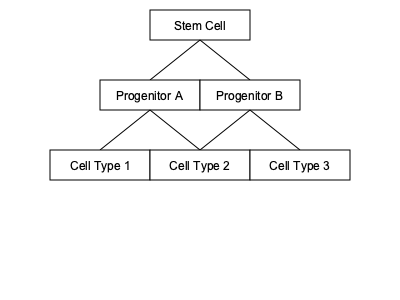In the stem cell differentiation flowchart above, how many distinct cell types are produced from the initial stem cell? To determine the number of distinct cell types produced from the initial stem cell, we need to follow the differentiation pathway:

1. The process starts with a single stem cell at the top of the flowchart.

2. This stem cell differentiates into two types of progenitor cells: Progenitor A and Progenitor B. These are intermediate cell types and not considered final differentiated cells.

3. Progenitor A then differentiates into two distinct cell types: Cell Type 1 and Cell Type 2.

4. Progenitor B differentiates into Cell Type 3.

5. Counting the final differentiated cells at the bottom of the flowchart, we can see three distinct cell types: Cell Type 1, Cell Type 2, and Cell Type 3.

Therefore, the initial stem cell ultimately produces three distinct cell types through this differentiation process.
Answer: 3 